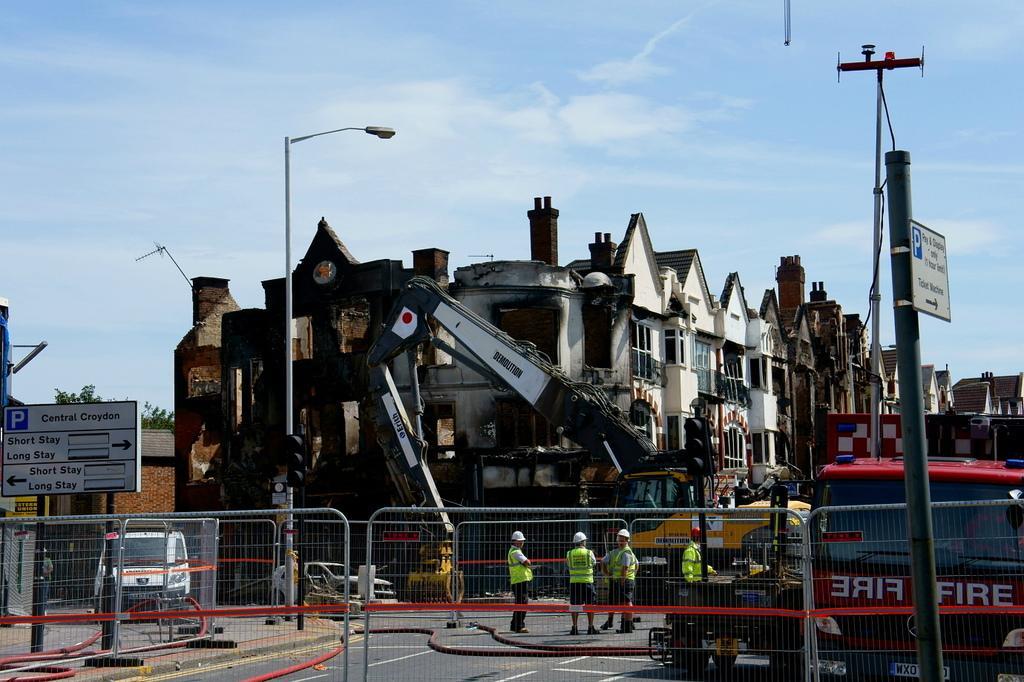Please provide a concise description of this image. In the given image i can see a buildings with windows,electrical poles,vehicles,people,fence,boards,crane,pole and in the background i can see the sky. 